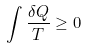Convert formula to latex. <formula><loc_0><loc_0><loc_500><loc_500>\int { \frac { \delta Q } { T } } \geq 0</formula> 